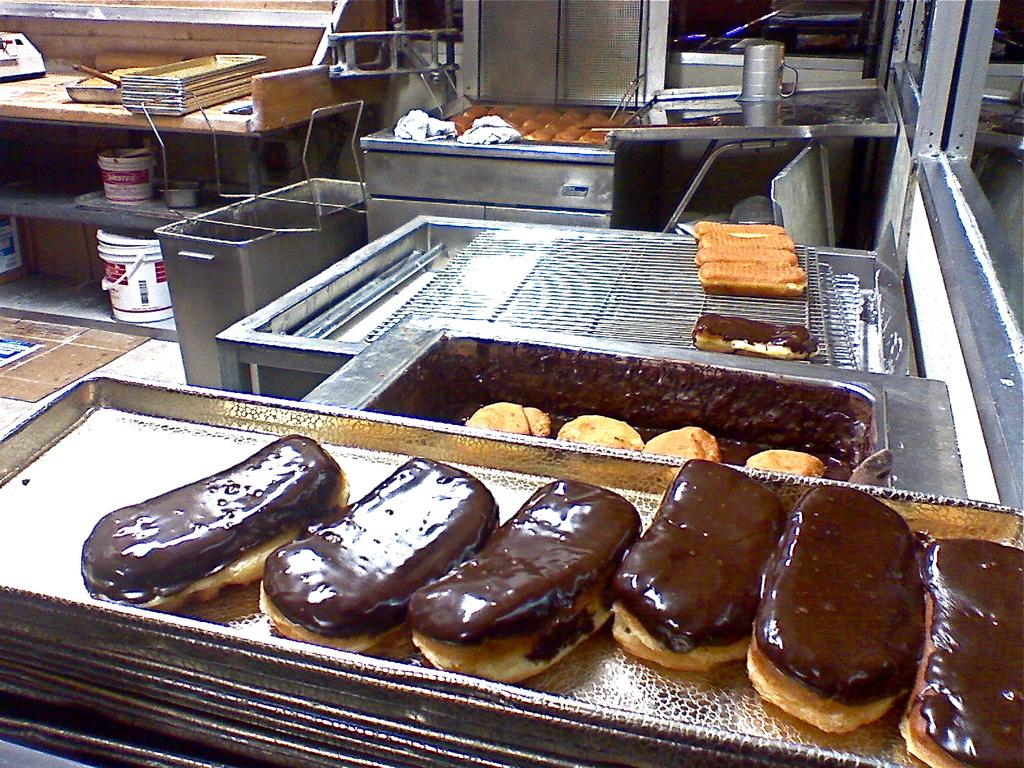What can be found in the trays in the image? There are food items in the trays in the image. What type of containers are present in the image? There are buckets in the image. What tools are visible in the image? There are utensils in the image. Can you describe any other objects in the image? There are other unspecified objects in the image. How many rabbits can be seen in the image? There are no rabbits present in the image. What type of knowledge is being shared in the image? There is no indication of any knowledge being shared in the image; it primarily features objects such as food items, buckets, and utensils. 